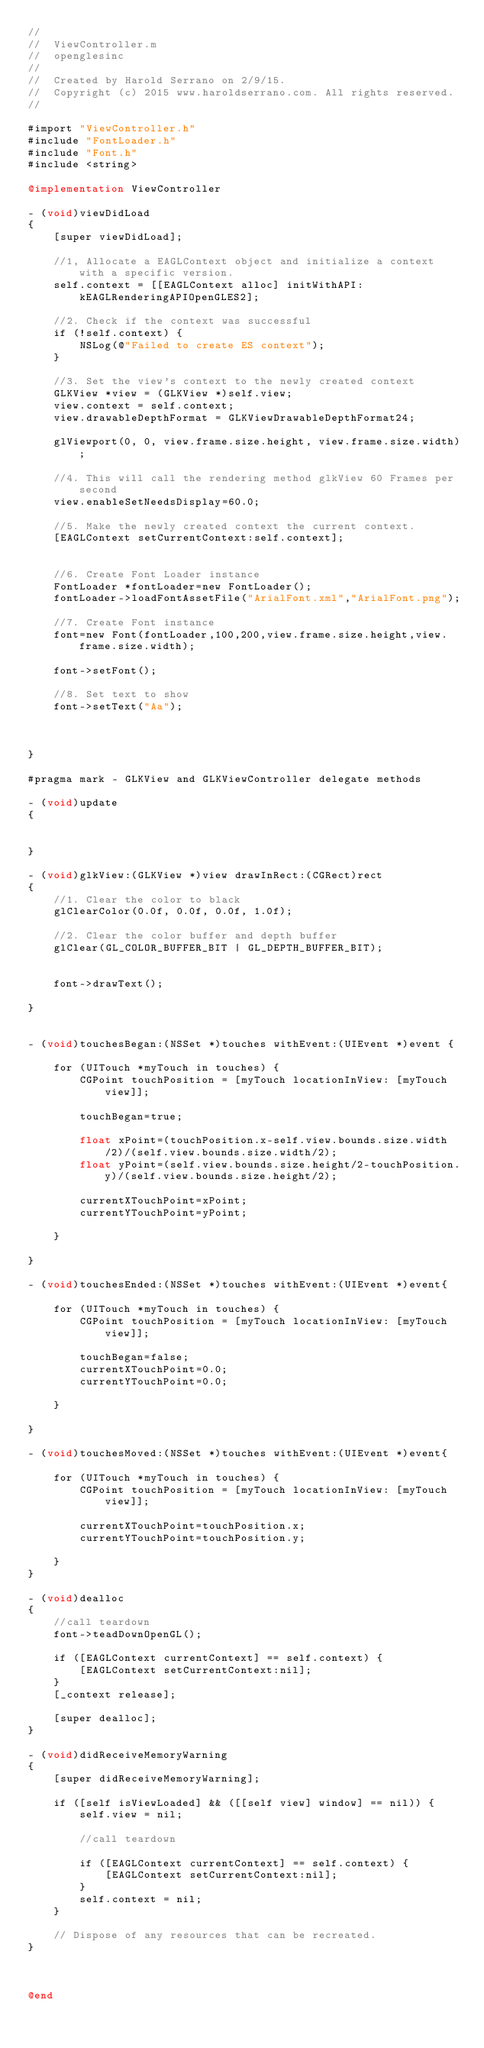<code> <loc_0><loc_0><loc_500><loc_500><_ObjectiveC_>//
//  ViewController.m
//  openglesinc
//
//  Created by Harold Serrano on 2/9/15.
//  Copyright (c) 2015 www.haroldserrano.com. All rights reserved.
//

#import "ViewController.h"
#include "FontLoader.h"
#include "Font.h"
#include <string>

@implementation ViewController

- (void)viewDidLoad
{
    [super viewDidLoad];
    
    //1, Allocate a EAGLContext object and initialize a context with a specific version.
    self.context = [[EAGLContext alloc] initWithAPI:kEAGLRenderingAPIOpenGLES2];
    
    //2. Check if the context was successful
    if (!self.context) {
        NSLog(@"Failed to create ES context");
    }
    
    //3. Set the view's context to the newly created context
    GLKView *view = (GLKView *)self.view;
    view.context = self.context;
    view.drawableDepthFormat = GLKViewDrawableDepthFormat24;
    
    glViewport(0, 0, view.frame.size.height, view.frame.size.width);
    
    //4. This will call the rendering method glkView 60 Frames per second
    view.enableSetNeedsDisplay=60.0;
    
    //5. Make the newly created context the current context.
    [EAGLContext setCurrentContext:self.context];
    

    //6. Create Font Loader instance
    FontLoader *fontLoader=new FontLoader();
    fontLoader->loadFontAssetFile("ArialFont.xml","ArialFont.png");
    
    //7. Create Font instance
    font=new Font(fontLoader,100,200,view.frame.size.height,view.frame.size.width);
    
    font->setFont();
    
    //8. Set text to show
    font->setText("Aa");
    
  
    
}

#pragma mark - GLKView and GLKViewController delegate methods

- (void)update
{
   
    
}

- (void)glkView:(GLKView *)view drawInRect:(CGRect)rect
{
    //1. Clear the color to black
    glClearColor(0.0f, 0.0f, 0.0f, 1.0f);
    
    //2. Clear the color buffer and depth buffer
    glClear(GL_COLOR_BUFFER_BIT | GL_DEPTH_BUFFER_BIT);
    
    
    font->drawText();
    
}


- (void)touchesBegan:(NSSet *)touches withEvent:(UIEvent *)event {
    
    for (UITouch *myTouch in touches) {
        CGPoint touchPosition = [myTouch locationInView: [myTouch view]];
        
        touchBegan=true;
       
        float xPoint=(touchPosition.x-self.view.bounds.size.width/2)/(self.view.bounds.size.width/2);
        float yPoint=(self.view.bounds.size.height/2-touchPosition.y)/(self.view.bounds.size.height/2);
        
        currentXTouchPoint=xPoint;
        currentYTouchPoint=yPoint;
        
    }
    
}

- (void)touchesEnded:(NSSet *)touches withEvent:(UIEvent *)event{
    
    for (UITouch *myTouch in touches) {
        CGPoint touchPosition = [myTouch locationInView: [myTouch view]];
        
        touchBegan=false;
        currentXTouchPoint=0.0;
        currentYTouchPoint=0.0;
        
    }
    
}

- (void)touchesMoved:(NSSet *)touches withEvent:(UIEvent *)event{
    
    for (UITouch *myTouch in touches) {
        CGPoint touchPosition = [myTouch locationInView: [myTouch view]];
        
        currentXTouchPoint=touchPosition.x;
        currentYTouchPoint=touchPosition.y;
        
    }
}

- (void)dealloc
{
    //call teardown
    font->teadDownOpenGL();
    
    if ([EAGLContext currentContext] == self.context) {
        [EAGLContext setCurrentContext:nil];
    }
    [_context release];
    
    [super dealloc];
}

- (void)didReceiveMemoryWarning
{
    [super didReceiveMemoryWarning];
    
    if ([self isViewLoaded] && ([[self view] window] == nil)) {
        self.view = nil;
        
        //call teardown
        
        if ([EAGLContext currentContext] == self.context) {
            [EAGLContext setCurrentContext:nil];
        }
        self.context = nil;
    }
    
    // Dispose of any resources that can be recreated.
}



@end
</code> 